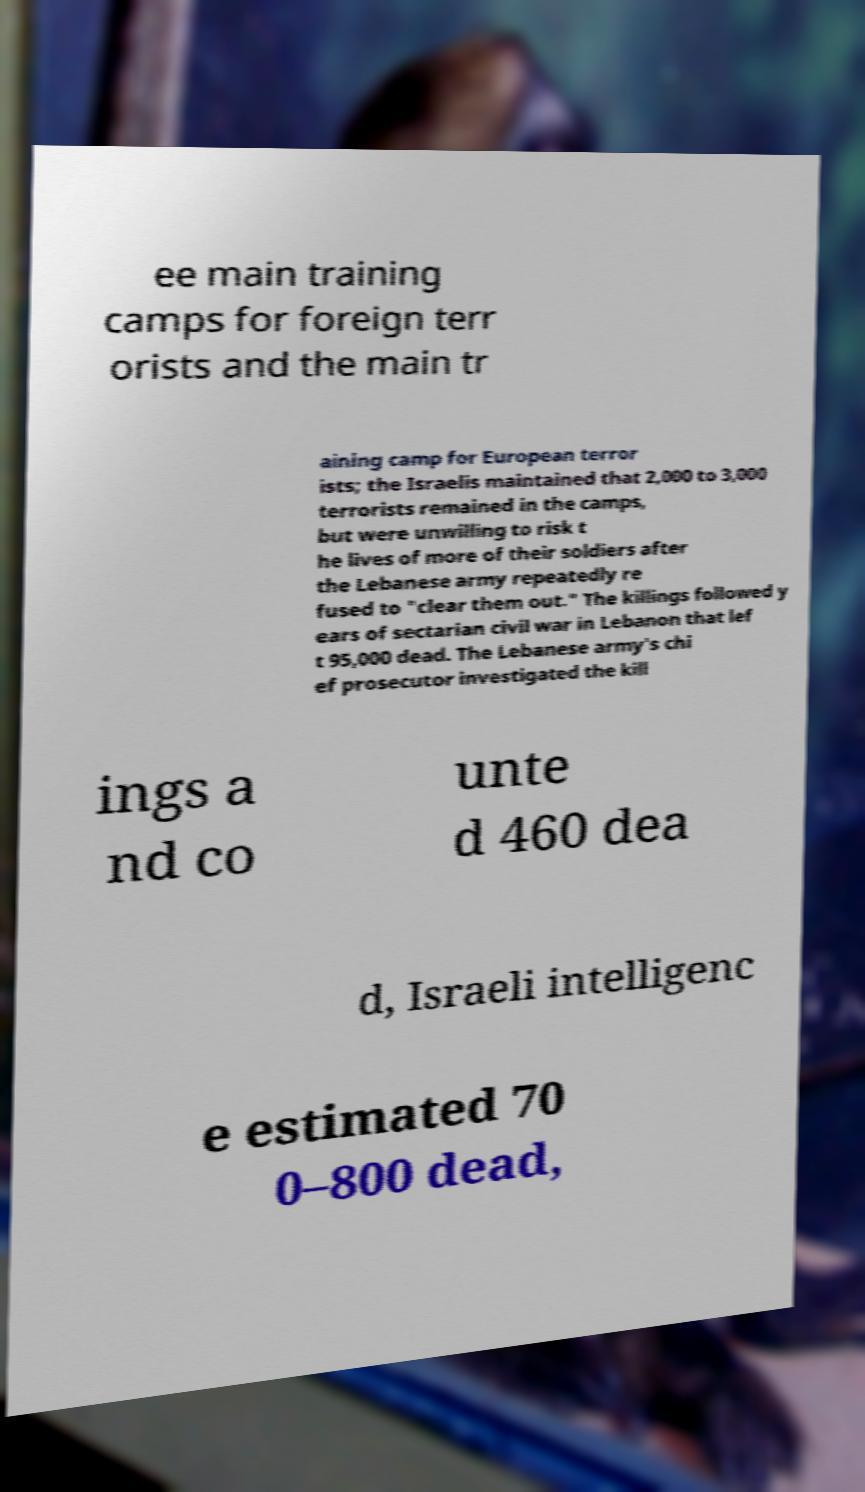Please read and relay the text visible in this image. What does it say? ee main training camps for foreign terr orists and the main tr aining camp for European terror ists; the Israelis maintained that 2,000 to 3,000 terrorists remained in the camps, but were unwilling to risk t he lives of more of their soldiers after the Lebanese army repeatedly re fused to "clear them out." The killings followed y ears of sectarian civil war in Lebanon that lef t 95,000 dead. The Lebanese army's chi ef prosecutor investigated the kill ings a nd co unte d 460 dea d, Israeli intelligenc e estimated 70 0–800 dead, 